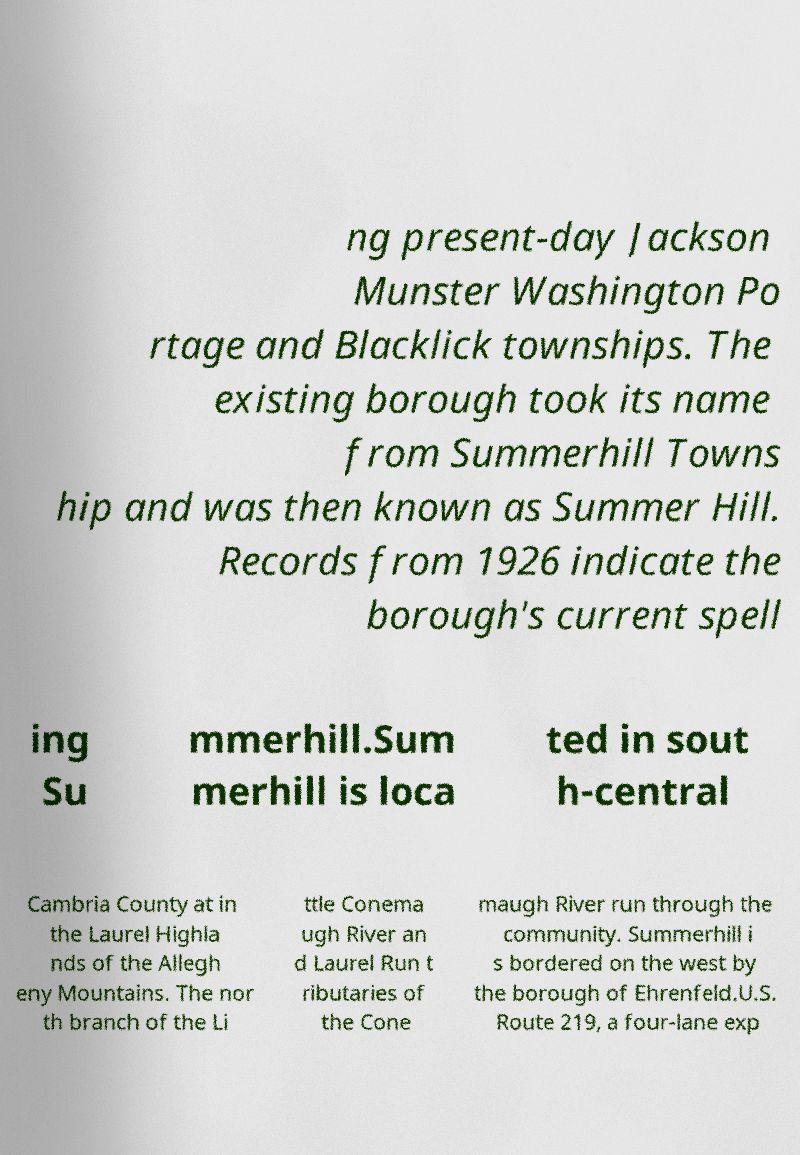What messages or text are displayed in this image? I need them in a readable, typed format. ng present-day Jackson Munster Washington Po rtage and Blacklick townships. The existing borough took its name from Summerhill Towns hip and was then known as Summer Hill. Records from 1926 indicate the borough's current spell ing Su mmerhill.Sum merhill is loca ted in sout h-central Cambria County at in the Laurel Highla nds of the Allegh eny Mountains. The nor th branch of the Li ttle Conema ugh River an d Laurel Run t ributaries of the Cone maugh River run through the community. Summerhill i s bordered on the west by the borough of Ehrenfeld.U.S. Route 219, a four-lane exp 